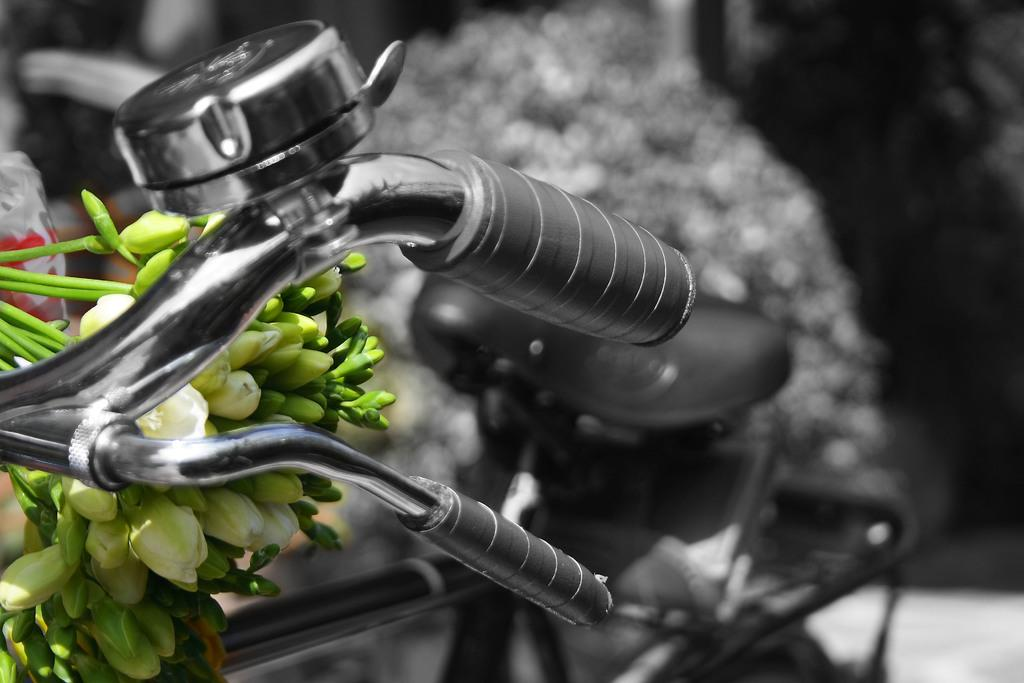What is the main object in the image? There is a bicycle in the image. What can be seen in the background of the image? There are plants in the background of the image. What color is the smoke coming out of the quarter in the image? There is no smoke or quarter present in the image. How does the neck of the bicycle contribute to its stability in the image? The bicycle in the image does not have a neck, as it is not a living creature. 